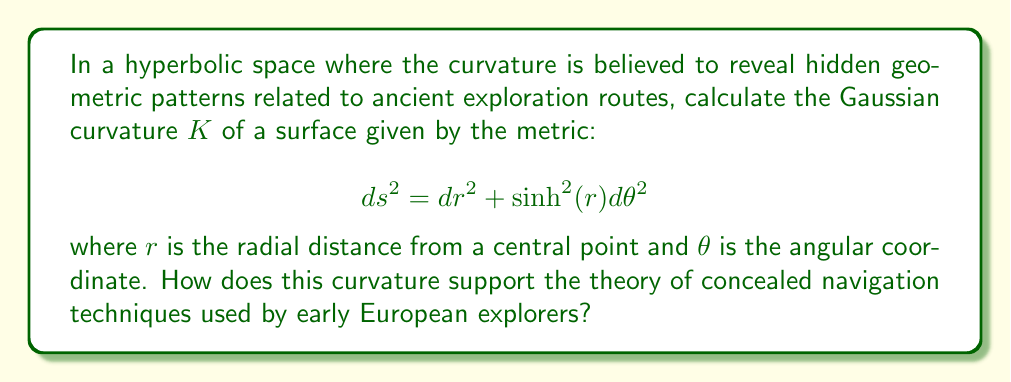Give your solution to this math problem. To calculate the Gaussian curvature $K$ of the given hyperbolic surface, we'll follow these steps:

1) The metric is given in the form:
   $$ ds^2 = dr^2 + f(r)^2 d\theta^2 $$
   where $f(r) = \sinh(r)$

2) For a surface with this metric form, the Gaussian curvature is given by:
   $$ K = -\frac{f''(r)}{f(r)} $$

3) Calculate $f'(r)$ and $f''(r)$:
   $f'(r) = \cosh(r)$
   $f''(r) = \sinh(r)$

4) Substitute into the curvature formula:
   $$ K = -\frac{\sinh(r)}{\sinh(r)} = -1 $$

5) The constant negative curvature of -1 reveals a perfectly uniform hyperbolic space, which could be interpreted as an ideal geometric structure for concealing navigation patterns.

6) This constant curvature suggests that early explorers might have used hyperbolic geometry to create maps that appeared distorted in Euclidean space but preserved distance relationships in hyperbolic space, potentially hiding their true routes from competitors.

7) The uniformity of the curvature could be seen as evidence of a deliberate design, possibly indicating a sophisticated understanding of non-Euclidean geometry among ancient navigators, supporting the theory of advanced hidden knowledge in early exploration.
Answer: $K = -1$ 